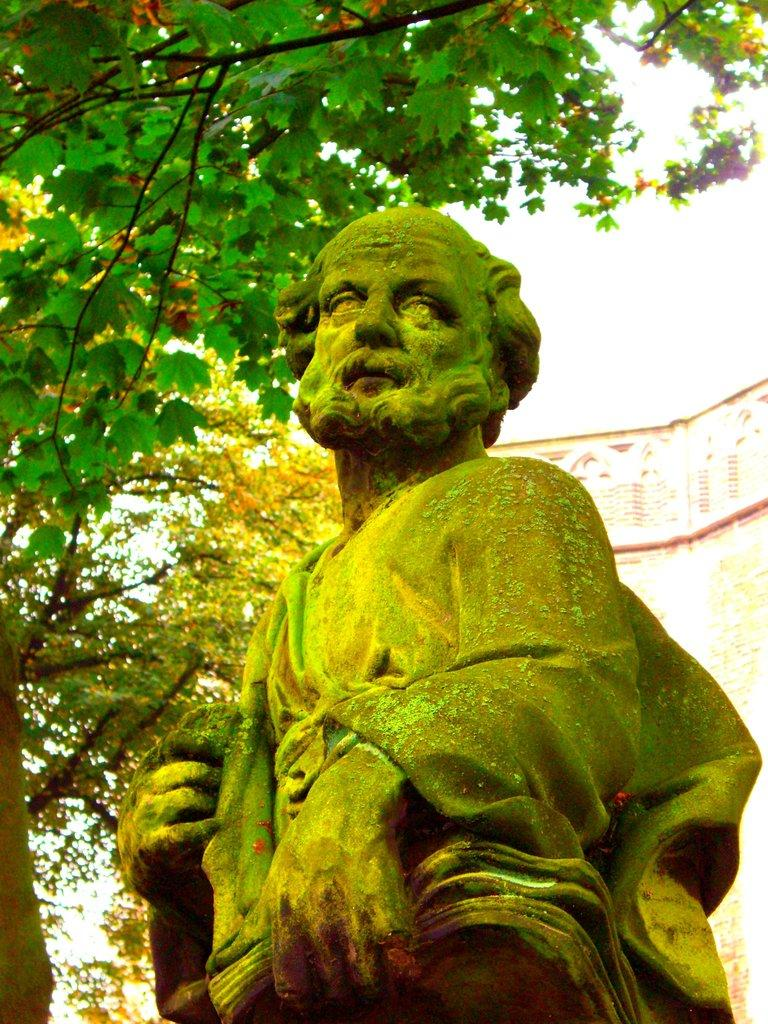What is the main subject in the image? There is a statue in the image. What can be seen in the background of the image? There are trees and the sky visible in the background of the image. What is the color of the trees in the image? The trees are green in the image. What is the color of the sky in the image? The sky is white in the image. Can you see a scarecrow kicking a pan in the image? There is no scarecrow or pan present in the image, and therefore no such activity can be observed. 